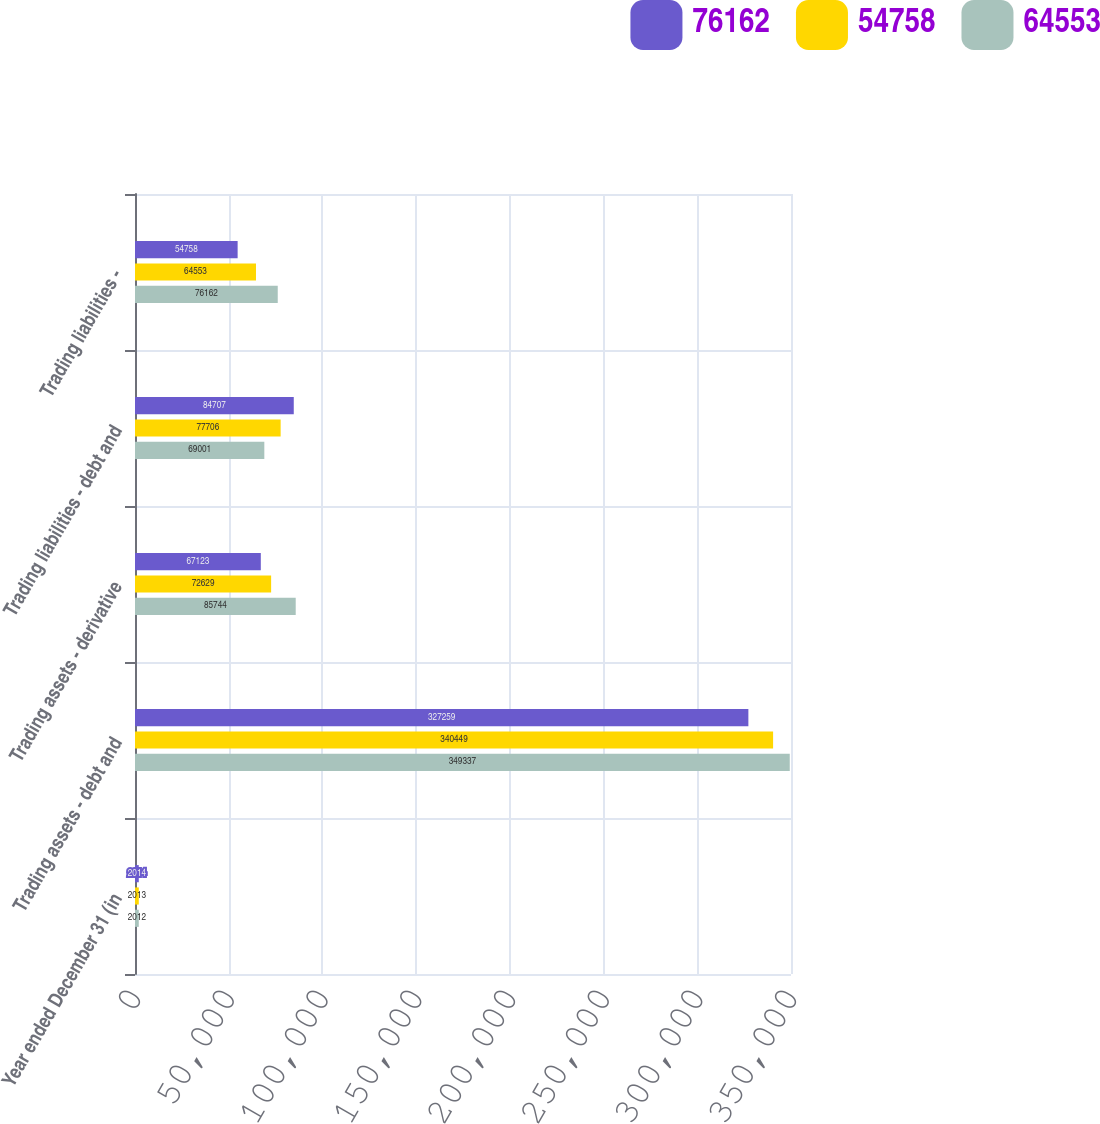<chart> <loc_0><loc_0><loc_500><loc_500><stacked_bar_chart><ecel><fcel>Year ended December 31 (in<fcel>Trading assets - debt and<fcel>Trading assets - derivative<fcel>Trading liabilities - debt and<fcel>Trading liabilities -<nl><fcel>76162<fcel>2014<fcel>327259<fcel>67123<fcel>84707<fcel>54758<nl><fcel>54758<fcel>2013<fcel>340449<fcel>72629<fcel>77706<fcel>64553<nl><fcel>64553<fcel>2012<fcel>349337<fcel>85744<fcel>69001<fcel>76162<nl></chart> 